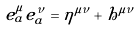Convert formula to latex. <formula><loc_0><loc_0><loc_500><loc_500>e ^ { \mu } _ { a } e ^ { \nu } _ { a } = \eta ^ { \mu \nu } + h ^ { \mu \nu }</formula> 